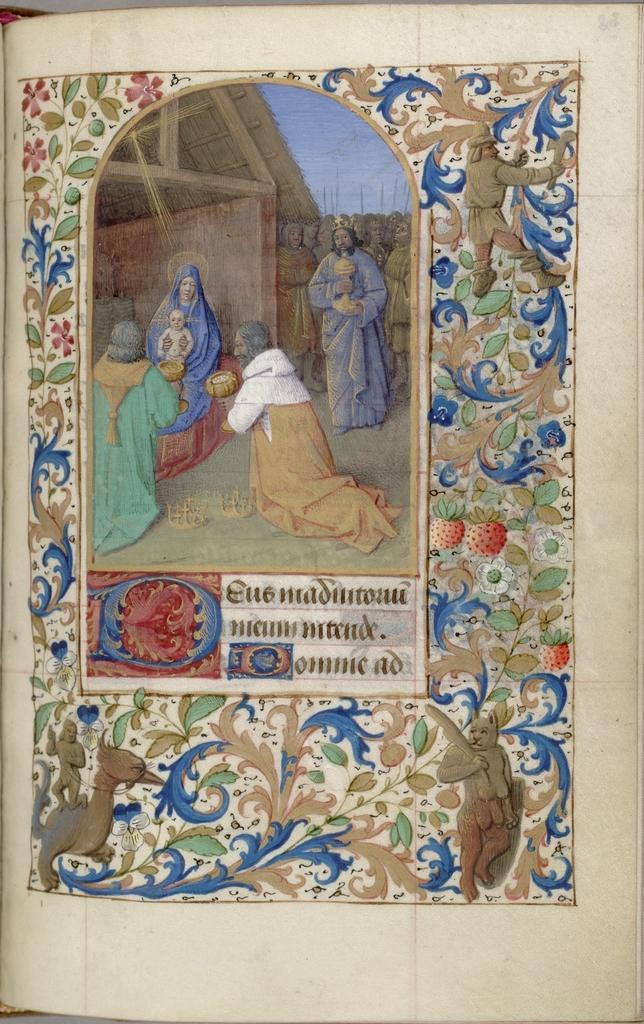What is present in the image that can be read or studied? There is a book in the image. What can be found inside the book? The book contains a picture of five people. What else can be seen in the image besides the book? There is a design visible in the image. What type of net is being used by the people in the image? There are no people visible in the image, only a book with a picture of five people. Additionally, there is no mention of a net in the provided facts. 